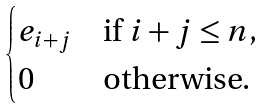<formula> <loc_0><loc_0><loc_500><loc_500>\begin{cases} e _ { i + j } & \text {if } i + j \leq n , \\ 0 & \text {otherwise} . \end{cases}</formula> 